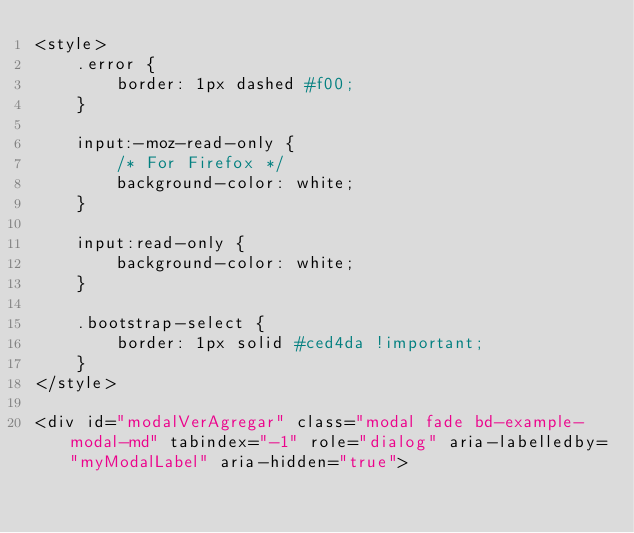<code> <loc_0><loc_0><loc_500><loc_500><_PHP_><style>
    .error {
        border: 1px dashed #f00;
    }

    input:-moz-read-only {
        /* For Firefox */
        background-color: white;
    }

    input:read-only {
        background-color: white;
    }

    .bootstrap-select {
        border: 1px solid #ced4da !important;
    }
</style>

<div id="modalVerAgregar" class="modal fade bd-example-modal-md" tabindex="-1" role="dialog" aria-labelledby="myModalLabel" aria-hidden="true"></code> 